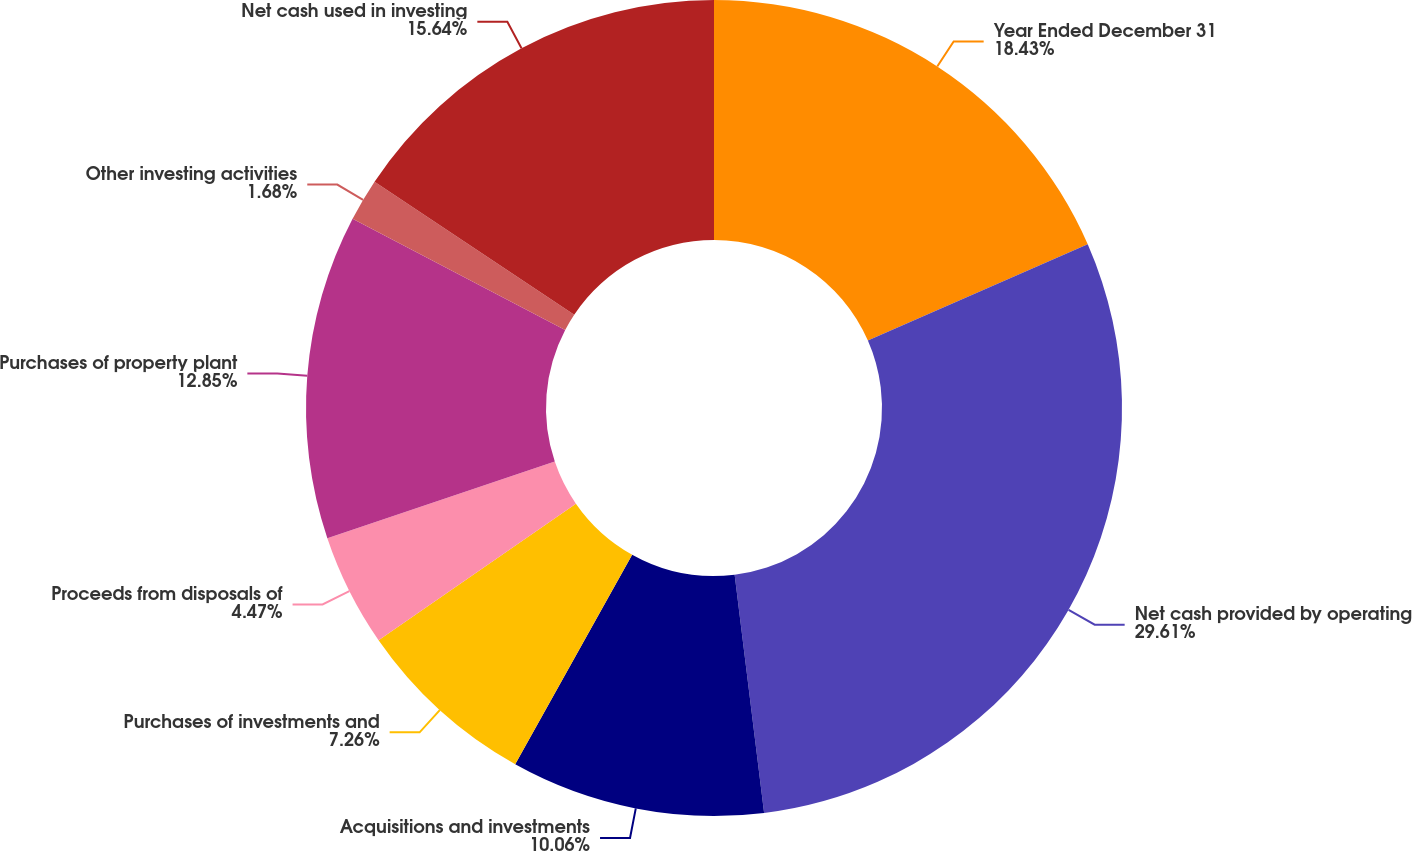<chart> <loc_0><loc_0><loc_500><loc_500><pie_chart><fcel>Year Ended December 31<fcel>Net cash provided by operating<fcel>Acquisitions and investments<fcel>Purchases of investments and<fcel>Proceeds from disposals of<fcel>Purchases of property plant<fcel>Other investing activities<fcel>Net cash used in investing<nl><fcel>18.43%<fcel>29.61%<fcel>10.06%<fcel>7.26%<fcel>4.47%<fcel>12.85%<fcel>1.68%<fcel>15.64%<nl></chart> 